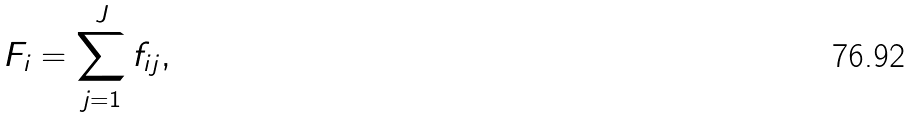Convert formula to latex. <formula><loc_0><loc_0><loc_500><loc_500>F _ { i } = \sum _ { j = 1 } ^ { J } f _ { i j } ,</formula> 